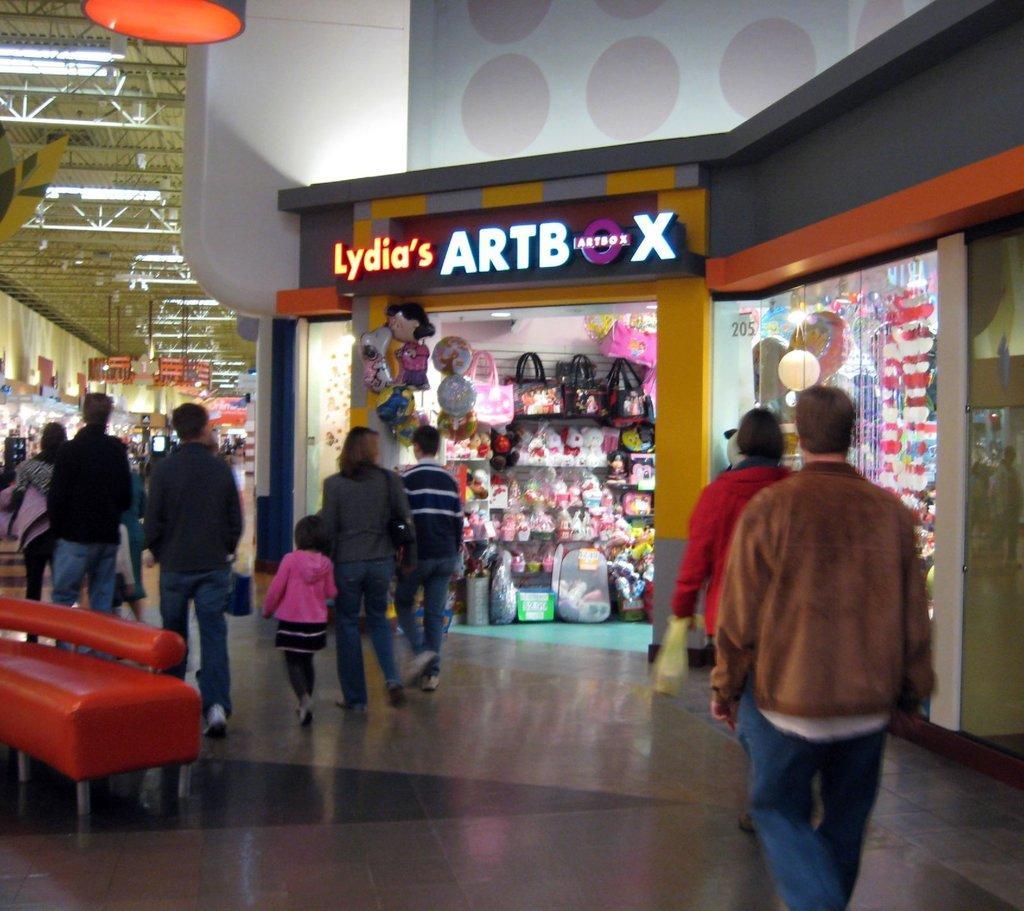Describe this image in one or two sentences. It is a store, in the right side a man is walking, he wore a coat. In the middle a woman is walking beside her a girl is also walking. In the right side there are toys in this store. 